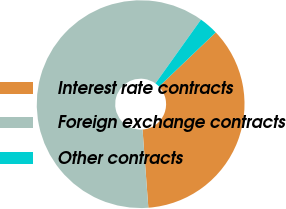Convert chart to OTSL. <chart><loc_0><loc_0><loc_500><loc_500><pie_chart><fcel>Interest rate contracts<fcel>Foreign exchange contracts<fcel>Other contracts<nl><fcel>35.96%<fcel>61.05%<fcel>3.0%<nl></chart> 